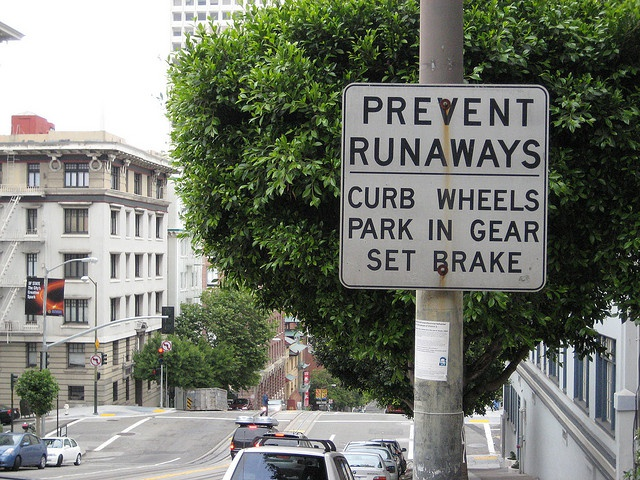Describe the objects in this image and their specific colors. I can see car in white, black, darkgray, and gray tones, car in white, gray, darkgray, and black tones, car in white, darkgray, lightgray, gray, and black tones, car in white, lightgray, darkgray, and gray tones, and car in white, lightgray, darkgray, gray, and black tones in this image. 